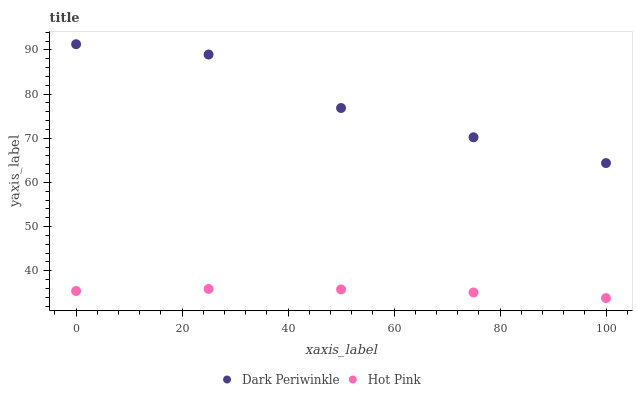Does Hot Pink have the minimum area under the curve?
Answer yes or no. Yes. Does Dark Periwinkle have the maximum area under the curve?
Answer yes or no. Yes. Does Dark Periwinkle have the minimum area under the curve?
Answer yes or no. No. Is Hot Pink the smoothest?
Answer yes or no. Yes. Is Dark Periwinkle the roughest?
Answer yes or no. Yes. Is Dark Periwinkle the smoothest?
Answer yes or no. No. Does Hot Pink have the lowest value?
Answer yes or no. Yes. Does Dark Periwinkle have the lowest value?
Answer yes or no. No. Does Dark Periwinkle have the highest value?
Answer yes or no. Yes. Is Hot Pink less than Dark Periwinkle?
Answer yes or no. Yes. Is Dark Periwinkle greater than Hot Pink?
Answer yes or no. Yes. Does Hot Pink intersect Dark Periwinkle?
Answer yes or no. No. 